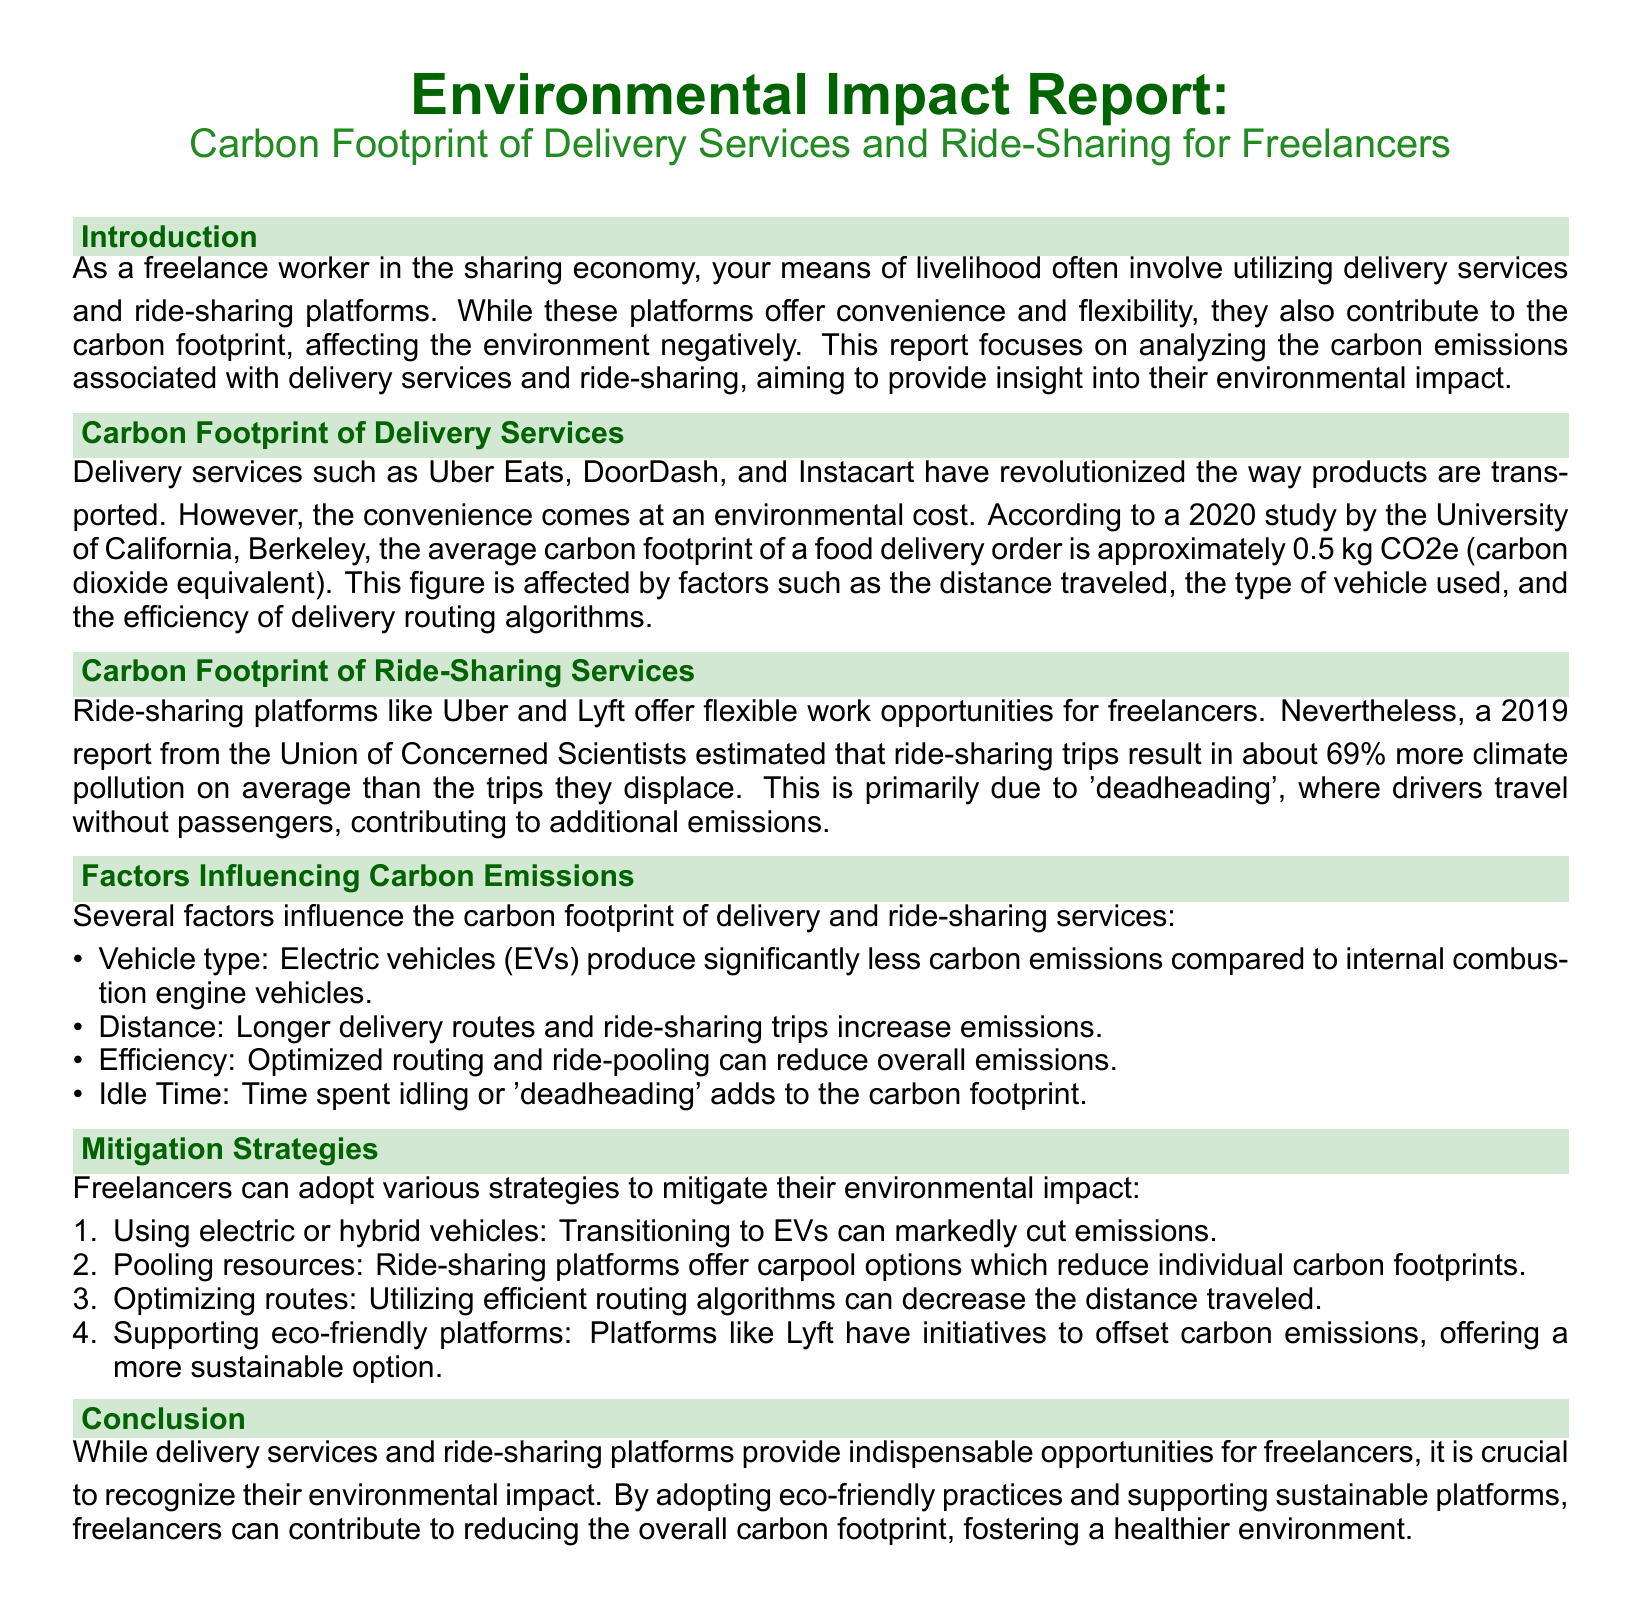what is the average carbon footprint of a food delivery order? The report states that the average carbon footprint of a food delivery order is approximately 0.5 kg CO2e.
Answer: 0.5 kg CO2e what percentage more climate pollution do ride-sharing trips produce on average? According to the report, ride-sharing trips result in about 69% more climate pollution on average than the trips they displace.
Answer: 69% what major factor contributes to additional emissions during ride-sharing? The document mentions 'deadheading' where drivers travel without passengers as a major contributor to additional emissions.
Answer: Deadheading which vehicle type produces significantly less carbon emissions? The report highlights that electric vehicles (EVs) produce significantly less carbon emissions compared to internal combustion engine vehicles.
Answer: Electric vehicles (EVs)  The report suggests that freelancers can adopt various strategies, including using electric or hybrid vehicles.
Answer: Use electric or hybrid vehicles how does optimized routing affect carbon emissions? The document states that optimized routing can reduce overall emissions, indicating its positive effect on carbon emissions.
Answer: Reduce overall emissions which platform has initiatives to offset carbon emissions? The report mentions that platforms like Lyft have initiatives to offset carbon emissions.
Answer: Lyft what type of report is this document classified as? The document describes itself as an Environmental Impact Report focusing on the carbon footprint of delivery services and ride-sharing.
Answer: Environmental Impact Report 